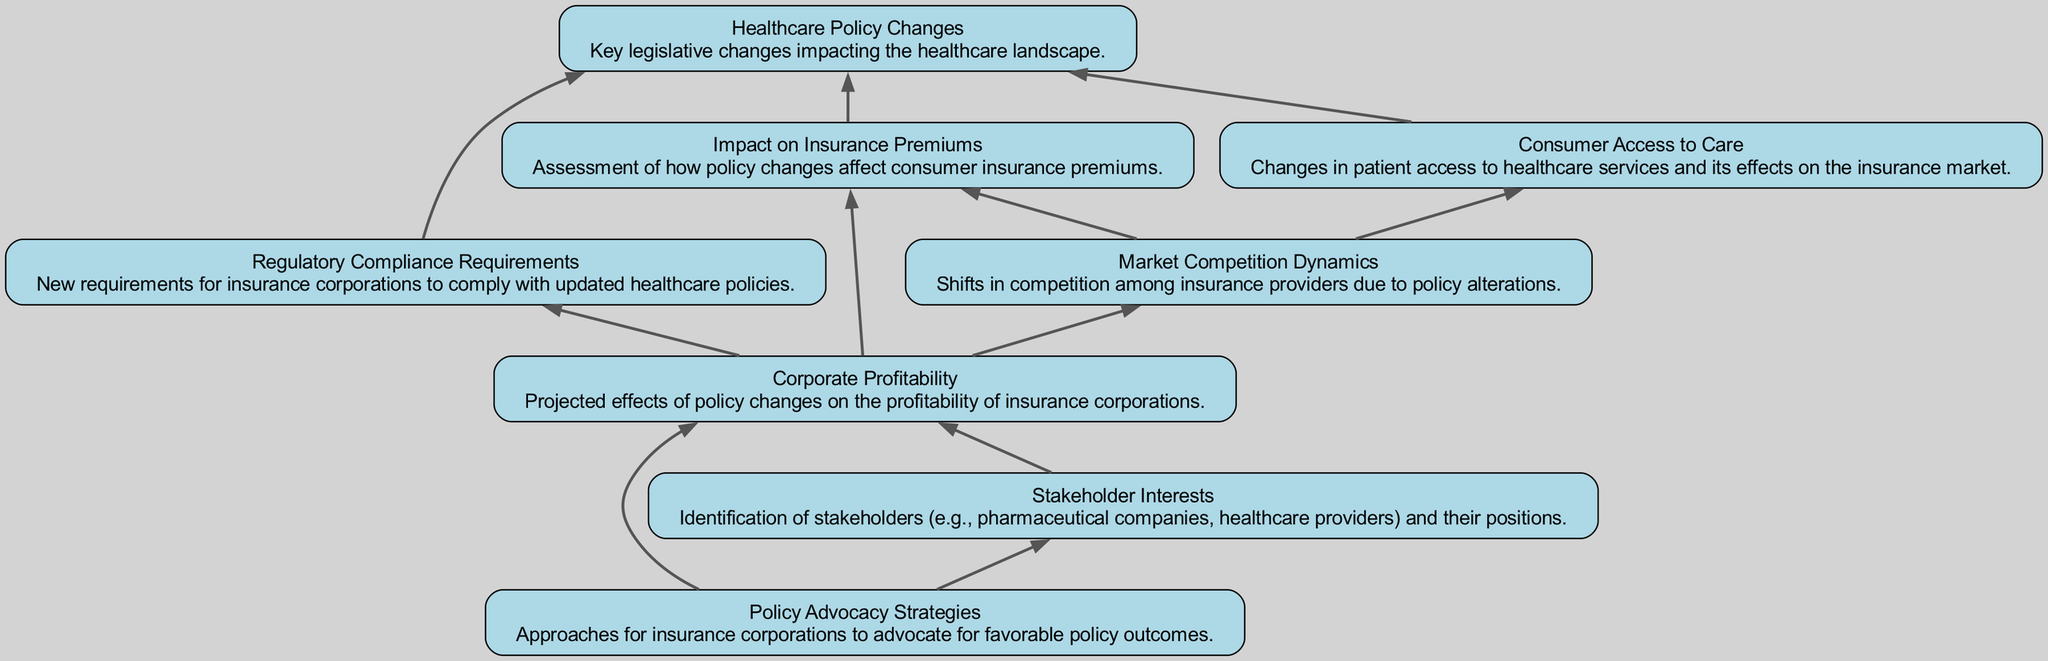What are the main healthcare policy changes highlighted? The diagram identifies "Healthcare Policy Changes" as the central theme, which encompasses key legislative changes.
Answer: Healthcare Policy Changes How many elements are depicted in the diagram? The diagram lists a total of eight distinct elements related to healthcare policy and its implications, represented by eight nodes.
Answer: Eight What is the relationship between "Impact on Insurance Premiums" and "Healthcare Policy Changes"? The arrow shows that "Impact on Insurance Premiums" feeds into "Healthcare Policy Changes," indicating that policy changes directly affect the insurance premiums consumers face.
Answer: Policy changes affect premiums What influences the "Corporate Profitability" node? "Corporate Profitability" is influenced by three nodes: "Impact on Insurance Premiums," "Regulatory Compliance Requirements," and "Market Competition Dynamics," as indicated by separate arrows leading into it.
Answer: Three nodes Which stakeholder is identified in the diagram and their connection? The stakeholder identified is "Stakeholder Interests," which connects to "Corporate Profitability" and "Policy Advocacy Strategies," reflecting their influence on these components of the insurance market.
Answer: Stakeholder Interests What is the flow direction of the "Policy Advocacy Strategies"? "Policy Advocacy Strategies" flows upward to "Corporate Profitability" and "Stakeholder Interests," showcasing the strategies' role in potentially enhancing profitability and identifying stakeholder positions.
Answer: Upward Which node is affected by "Market Competition Dynamics"? "Impact on Insurance Premiums" and "Consumer Access to Care" are affected by "Market Competition Dynamics," illustrating how competition among insurers impacts both consumer costs and access to healthcare services.
Answer: Two nodes What does "Regulatory Compliance Requirements" directly depend on? It directly depends on "Healthcare Policy Changes," which means changes in policy create new compliance needs for insurance companies.
Answer: Healthcare Policy Changes 